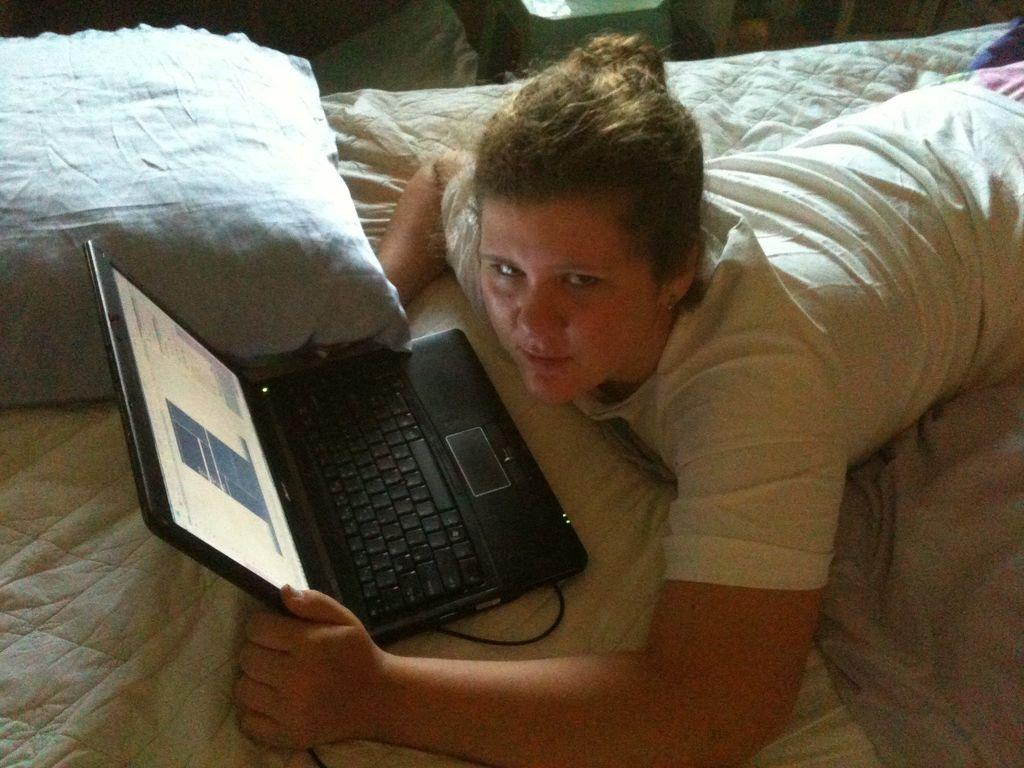What is the person doing in the image? The person is laying on the bed. What is the person holding while laying on the bed? The person is holding a laptop. What is present on the bed for comfort? There is a pillow on the bed. What can be seen in the background of the image? There are objects in the background of the image. What type of church can be seen in the background of the image? There is no church present in the background of the image. What is the person using to write on the desk in the image? There is no desk present in the image, and the person is not writing. 